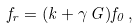<formula> <loc_0><loc_0><loc_500><loc_500>f _ { r } = ( k + \gamma \, G ) f _ { 0 } \, ,</formula> 